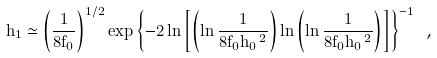<formula> <loc_0><loc_0><loc_500><loc_500>h _ { 1 } \simeq \left ( \frac { 1 } { 8 f _ { 0 } } \right ) ^ { 1 / 2 } \exp \left \{ - 2 \ln \left [ \left ( \ln \frac { 1 } { 8 f _ { 0 } h _ { 0 } \, ^ { 2 } } \right ) \ln \left ( \ln \frac { 1 } { 8 f _ { 0 } h _ { 0 } \, ^ { 2 } } \right ) \right ] \right \} ^ { - 1 } \ ,</formula> 